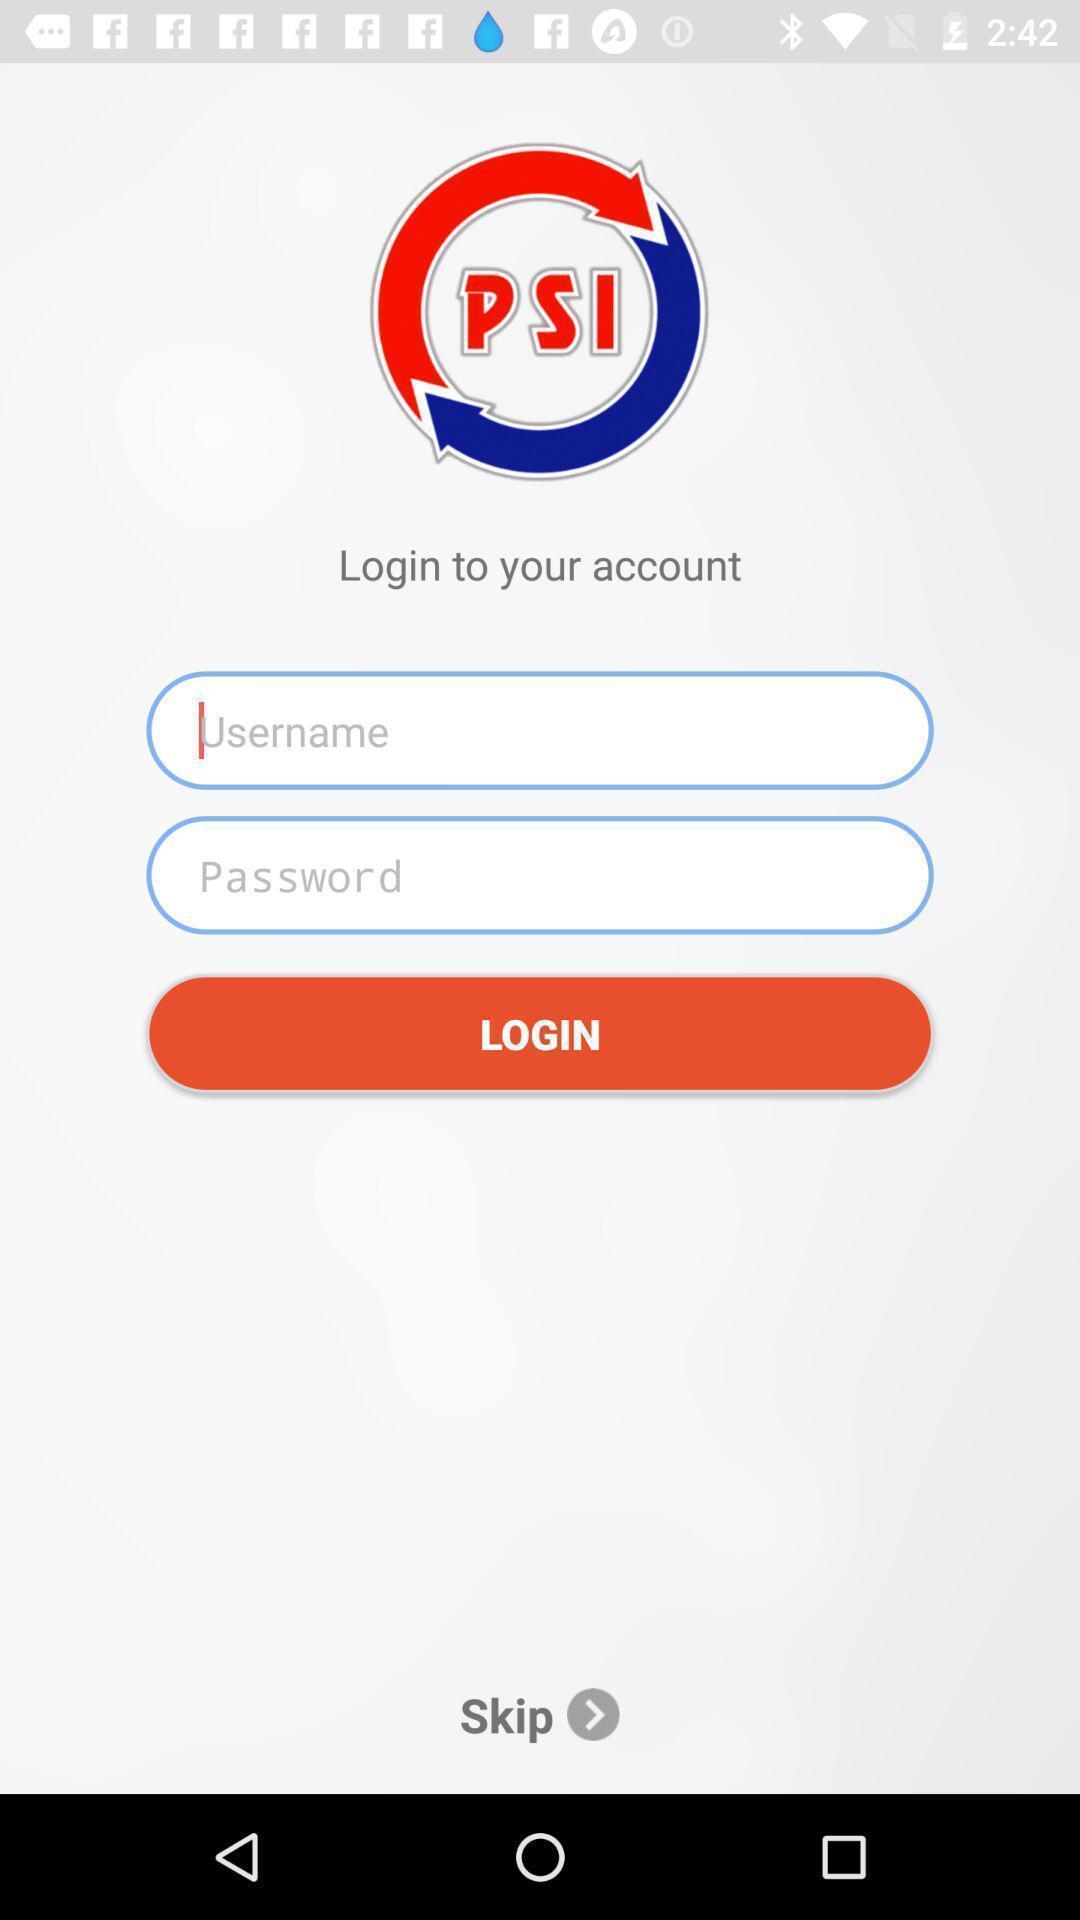Give me a summary of this screen capture. Welcome page for learning app. 